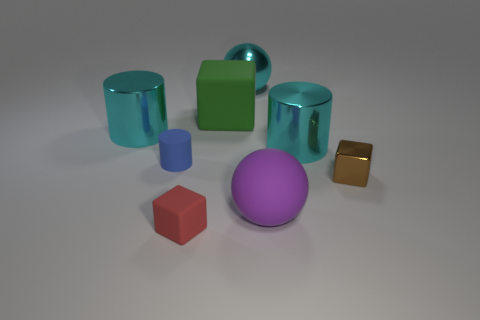What shape is the blue object that is made of the same material as the purple thing?
Provide a short and direct response. Cylinder. Is there any other thing of the same color as the small cylinder?
Offer a very short reply. No. Are there more blue cylinders behind the tiny shiny cube than metallic cylinders that are to the left of the green thing?
Provide a short and direct response. No. How many spheres are the same size as the green cube?
Your answer should be very brief. 2. Are there fewer green matte objects that are behind the large green matte object than large cyan shiny things that are to the left of the tiny blue matte cylinder?
Offer a very short reply. Yes. Are there any purple objects that have the same shape as the tiny red object?
Provide a succinct answer. No. Is the shape of the tiny brown thing the same as the large green matte object?
Your response must be concise. Yes. What number of tiny objects are shiny things or purple things?
Provide a succinct answer. 1. Is the number of small purple objects greater than the number of small rubber cylinders?
Provide a short and direct response. No. What is the size of the block that is made of the same material as the large cyan sphere?
Offer a terse response. Small. 